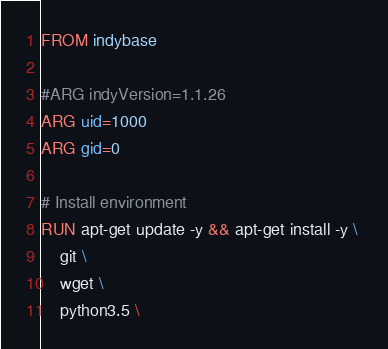Convert code to text. <code><loc_0><loc_0><loc_500><loc_500><_Dockerfile_>FROM indybase

#ARG indyVersion=1.1.26
ARG uid=1000
ARG gid=0

# Install environment
RUN apt-get update -y && apt-get install -y \ 
	git \
	wget \
	python3.5 \</code> 